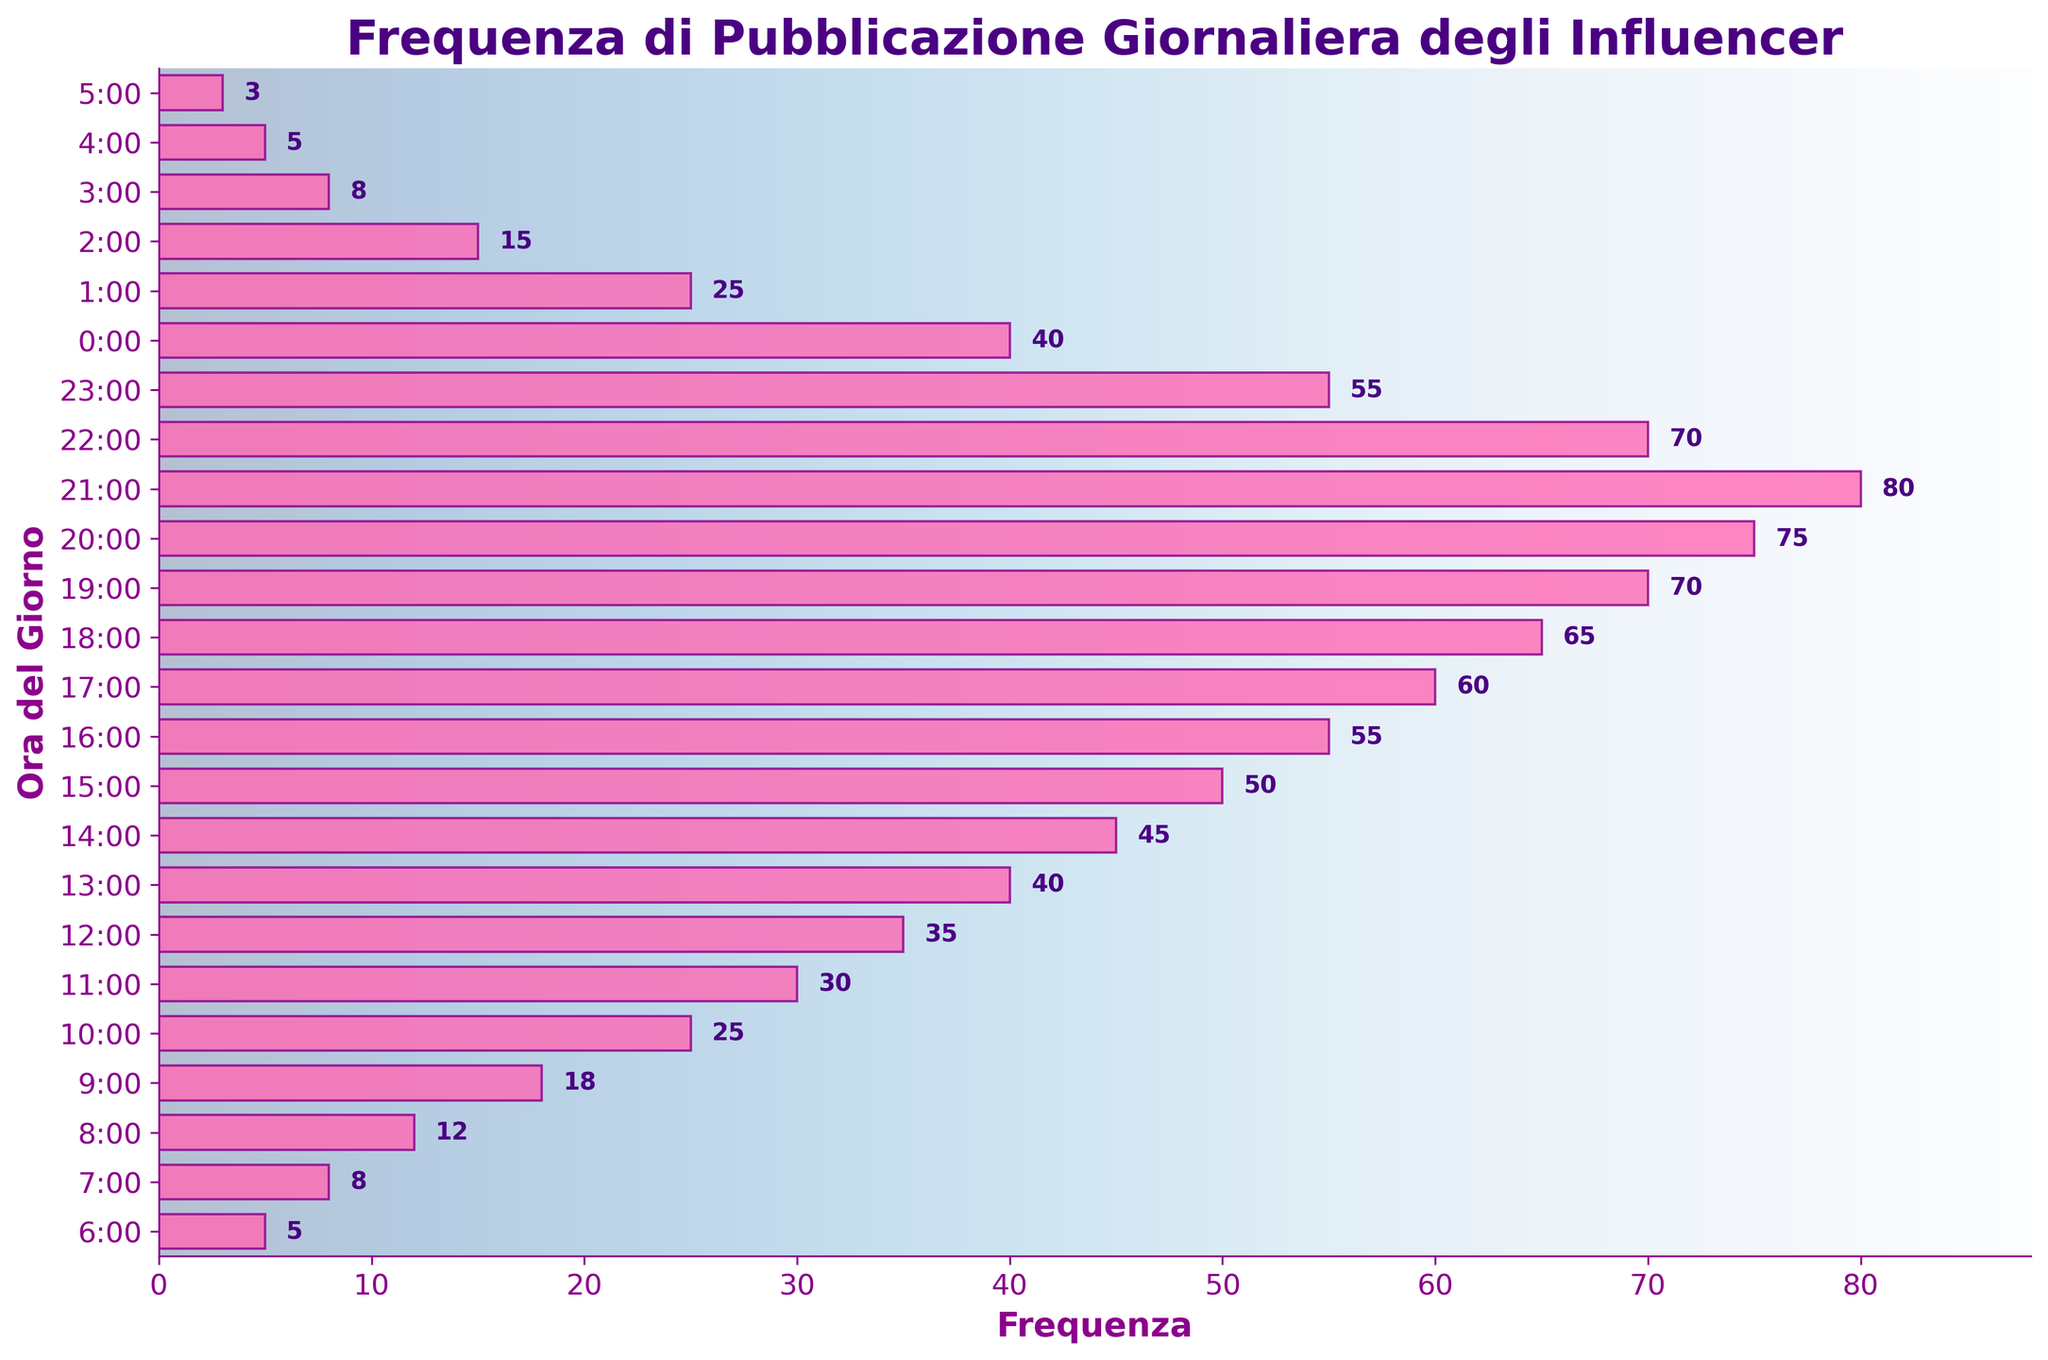What is the title of the plot? The title of the plot can be found at the top center of the figure, indicating what the plot is about.
Answer: Frequenza di Pubblicazione Giornaliera degli Influencer What is the frequency value at 17:00? Look at the horizontal bar corresponding to 17:00 on the vertical axis and read the length of the bar, then check the embedded text above it for the frequency value.
Answer: 60 During which hour is the posting frequency the highest? Look for the longest horizontal bar on the plot and check the corresponding time on the vertical axis.
Answer: 21:00 What is the combined posting frequency for 7:00 and 19:00? Find the frequency values at 7:00 (8) and 19:00 (70), then add them together: 8 + 70.
Answer: 78 How many hours have a posting frequency greater than 50? Count all the bars where the frequency value shown exceeds 50. There are 75 at 20:00, 80 at 21:00, 70 at 22:00, 55 at 23:00, and 60 at 17:00 - total 5 hours.
Answer: 5 What is the average posting frequency between 12:00 and 14:00? Find the frequencies at 12:00 (35), 13:00 (40), and 14:00 (45). Calculate the average: (35 + 40 + 45) / 3.
Answer: 40 Compare the posting frequency at 12:00 with that at 0:00. Which one is higher and by how much? The frequency at 12:00 is 35 and at 0:00 it’s 40. Subtract 35 from 40 to find the difference, so 0:00 is higher.
Answer: 5 At which hour does the posting frequency start to decrease after reaching its peak? Identify the peak frequency at 21:00 (80), then find the next hour where the posting frequency decreases, 22:00 with 70.
Answer: 21:00 What is the posting frequency at the earliest time given in the plot? Look at the horizontal bar corresponding to the earliest time, 6:00, on the vertical axis.
Answer: 5 How many times does the posting frequency exceed 60? Count the number of bars with frequencies exceeding 60, which are 65 at 18:00, 70 at 19:00, 75 at 20:00, and 80 at 21:00.
Answer: 4 